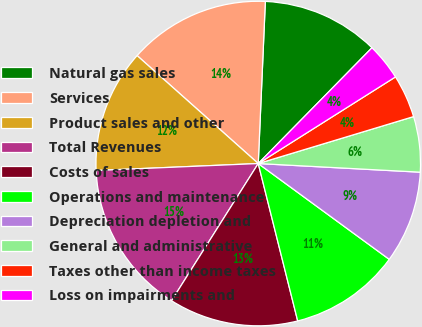Convert chart. <chart><loc_0><loc_0><loc_500><loc_500><pie_chart><fcel>Natural gas sales<fcel>Services<fcel>Product sales and other<fcel>Total Revenues<fcel>Costs of sales<fcel>Operations and maintenance<fcel>Depreciation depletion and<fcel>General and administrative<fcel>Taxes other than income taxes<fcel>Loss on impairments and<nl><fcel>11.66%<fcel>14.11%<fcel>12.27%<fcel>15.34%<fcel>12.88%<fcel>11.04%<fcel>9.2%<fcel>5.52%<fcel>4.29%<fcel>3.68%<nl></chart> 